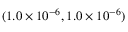Convert formula to latex. <formula><loc_0><loc_0><loc_500><loc_500>( 1 . 0 \times 1 0 ^ { - 6 } , 1 . 0 \times 1 0 ^ { - 6 } )</formula> 